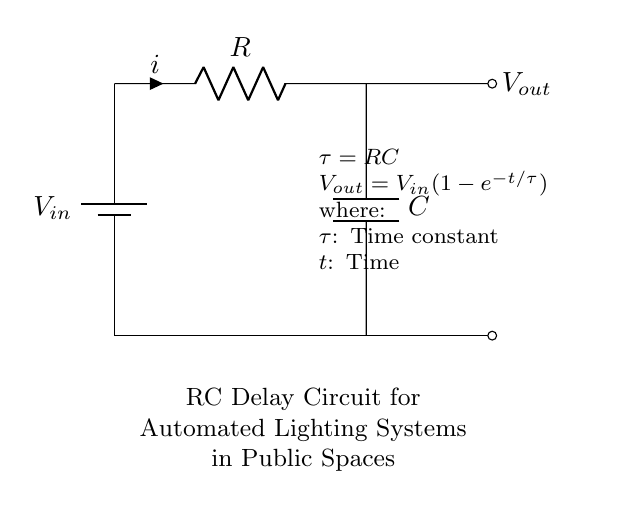What is the input voltage in this circuit? The input voltage symbol is labeled as V_in, signifying where the voltage is applied in the circuit.
Answer: V_in What does the resistor represent in this circuit? The resistor is labeled as R, indicating its role in limiting current flow within the circuit.
Answer: R What do the letters C and R signify in this diagram? C represents the capacitance of the capacitor, while R signifies the resistance of the resistor, both essential for determining the time constant in the circuit.
Answer: C, R What is the formula for the time constant in this circuit? The time constant (τ) is defined as the product of resistance (R) and capacitance (C), which indicates how quickly the circuit responds to changes.
Answer: τ = RC What does the output voltage depend on? The output voltage (V_out) is a function of the input voltage (V_in), the time (t), and the time constant (τ), which together describe how V_out changes over time.
Answer: V_out = V_in(1-e^{-t/τ}) How does increasing the capacitance affect the circuit? Increasing the capacitance (C) increases the time constant (τ = RC), which results in a slower charging rate for the capacitor, thus leading to a longer delay before reaching a certain voltage at V_out.
Answer: Slower charging rate 